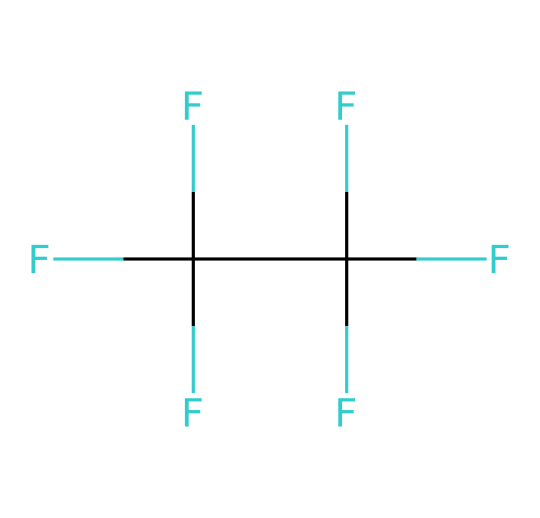How many carbon atoms are in this hydrofluorocarbon? To determine the number of carbon atoms, we identify the central carbon in the given SMILES representation and check for any additional carbons attached. The structure has one carbon as the core atom connected to three fluorine atoms, and there are two more surrounding carbon atoms, leading to a total of four carbon atoms.
Answer: four What is the molecular formula of this compound? The SMILES notation indicates the atoms present: one carbon connected to three fluorine (CF3) and an additional carbon attached to tetrafluorine atoms (CF4), yielding a compound of C2H4F6 when considering all attachments.
Answer: C2H4F6 What type of bonds are present in this chemical? Analyzing the SMILES shows that the connections between carbon and fluorine atoms are single and fully saturated, indicating that the bonds are single covalent bonds throughout the entire structure.
Answer: single covalent Why is this compound considered a refrigerant? This compound, being a hydrofluorocarbon, possesses a low boiling point and a high vapor pressure at room temperature, allowing it to efficiently absorb heat in cooling systems, thereby categorizing it as a refrigerant.
Answer: low boiling point How many fluorine atoms are present in this molecule? The visual interpretation of the SMILES depicts each carbon atom being connected to a total of six fluorine atoms overall in the structure, which indicates how many fluorine atoms exist in the molecule.
Answer: six What is the significance of HFCs like this compound in environmental science? Hydrofluorocarbons, such as the one illustrated, are significant because they are used as alternatives to ozone-depleting substances and are less harmful to the stratospheric ozone layer while still having a global warming potential that raises environmental concerns.
Answer: less harmful to ozone What would happen if this compound is released into the atmosphere? The release of this compound into the atmosphere could contribute to greenhouse gas emissions, impacting climate change and global warming due to its high global warming potential.
Answer: contribute to warming 